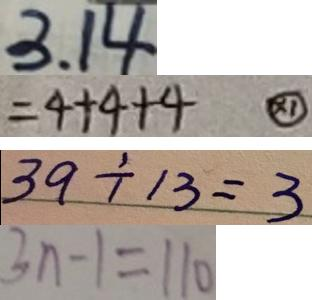Convert formula to latex. <formula><loc_0><loc_0><loc_500><loc_500>3 . 1 4 
 = 4 + 4 + 4 \textcircled { \times 1 } 
 3 9 \div 3 = 3 
 3 n - 1 = 1 1 0</formula> 